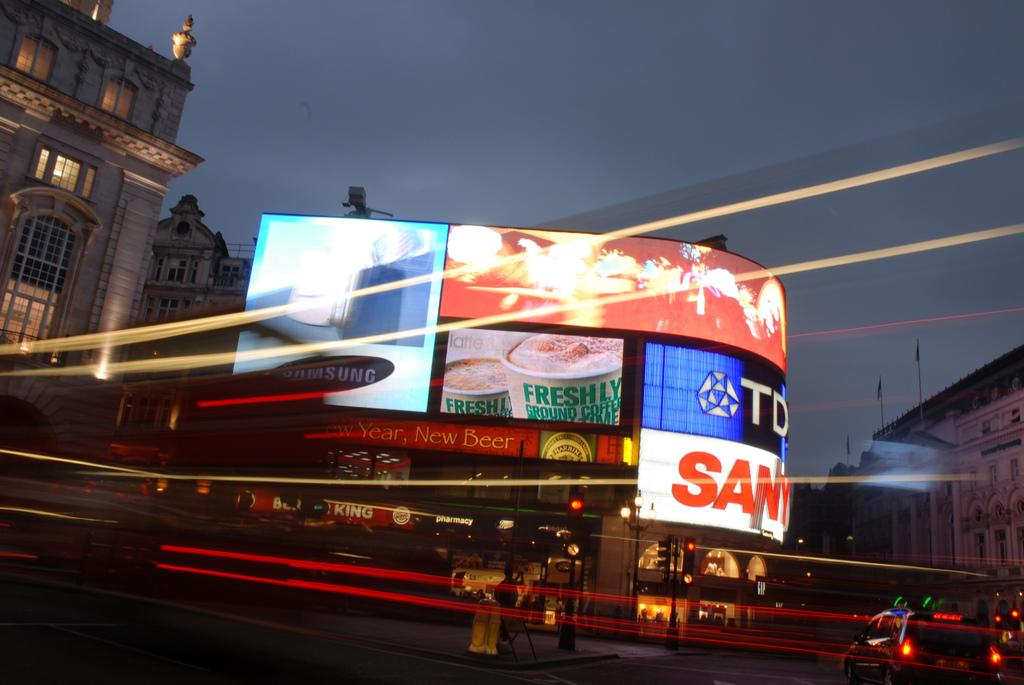<image>
Share a concise interpretation of the image provided. One of the billboards in this nighttime scene says "New Year, New Beer." 